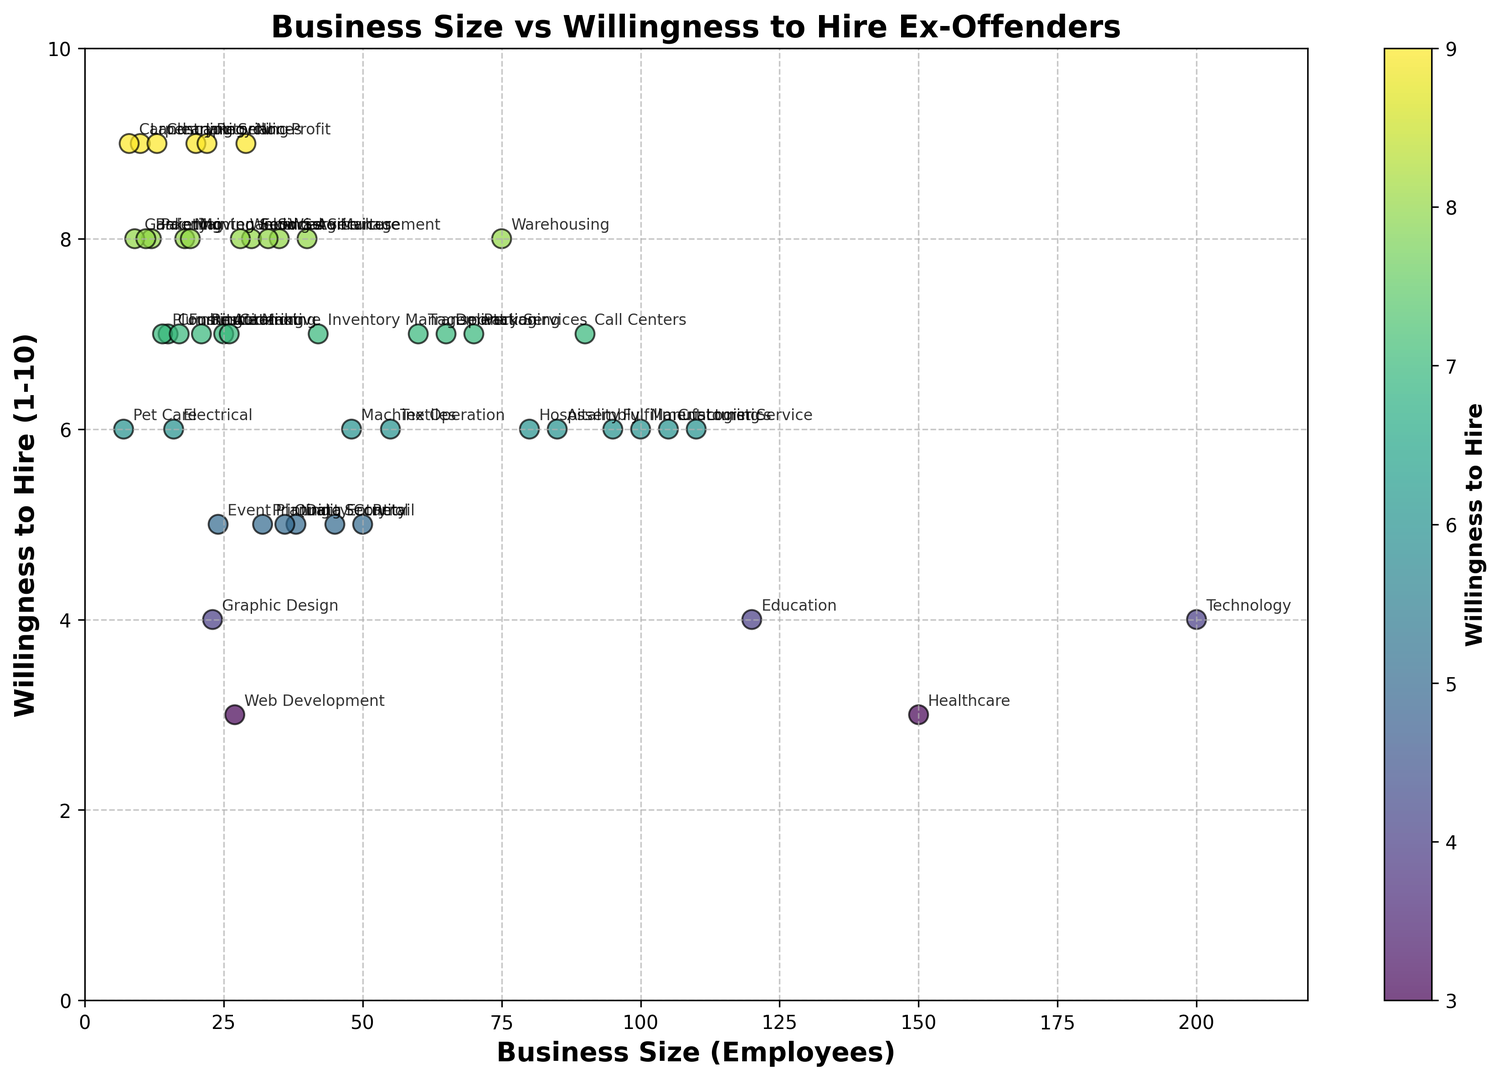Which industry has the largest business size? By observing the x-axis, Technology has the highest value of 200 employees, making it the largest business size in the plot.
Answer: Technology Which industry has the highest willingness to hire ex-offenders? By referring to the y-axis, both Landscaping, Janitorial, Agriculture, Maintenance, Carpentry, Recycling, Cleaning Services, Non-Profit have a willingness rating of 9, which is the highest on the plot.
Answer: Landscaping, Janitorial, Agriculture, Maintenance, Carpentry, Recycling, Cleaning Services, Non-Profit What is the average willingness to hire ex-offenders for industries with a business size less than 50 employees? Identify the industries with business sizes less than 50, find their willingness values, sum them up and divide by the number of such industries ((15, 7), (10, 9), (25, 7), (20, 9), (35, 8), (18, 8), (22, 9), (12, 8), (14, 7), (16, 6), (28, 8), (32, 5), (26, 7), (7, 6), (13, 9), (19, 8), (9, 8), (17, 7), (11, 8), (21, 7), (23, 8), (29, 9), total=22 industries) => (7+9+7+9+8+8+9+8+7+6+8+5+7+6+9+8+8+7+8+7+8+9)/22 = 7.5
Answer: 7.5 Which industry with more than 100 employees shows the lowest willingness to hire ex-offenders? Scan the plot for industries with business sizes greater than 100 employees, and compare their willingness to hire values. Healthcare with 3 and Technology and Education also have values of 4, but Healthcare is the lowest.
Answer: Healthcare Between Construction and Food Service, which industry is more willing to hire ex-offenders? Compare the y-axis values for Construction (7) and Food Service (8). Food Service has a higher willingness to hire ex-offenders.
Answer: Food Service What is the overall trend between business size and willingness to hire? Observe the scatter plot for patterns. Generally, smaller businesses seem to have higher willingness ratings compared to larger businesses. The willingness decreases as the business size increases overall.
Answer: Smaller businesses tend to be more willing What industries are clustered around a willingness to hire value of 8? Look at the points near y=8 on the plot. Industries near this value include Food Service, Agriculture, Waste Management, Maintenance, Painting, Welding, Moving Services, Social Services, and Bakery.
Answer: Food Service, Agriculture, Waste Management, Maintenance, Painting, Welding, Moving Services, Social Services, Bakery Which two industries with similar business sizes have the largest difference in willingness to hire? Identify pairs of industries with similar business sizes and compare their willingness to hire values. Technology (willingness=4, size=200) and Healthcare (willingness=3, size=150) have similar sizes but not the largest difference. Then look at Retail (5, 50) and Data Entry (5, 38). Finally, compare Call Centers (7, 90) and Assembly (6, 85). A significant difference: Data Entry (5) and Waste Management (8) both have 35 employees.
Answer: Data Entry, Waste Management 